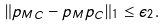Convert formula to latex. <formula><loc_0><loc_0><loc_500><loc_500>\| p _ { M C } - p _ { M } p _ { C } \| _ { 1 } \leq \epsilon _ { 2 } .</formula> 